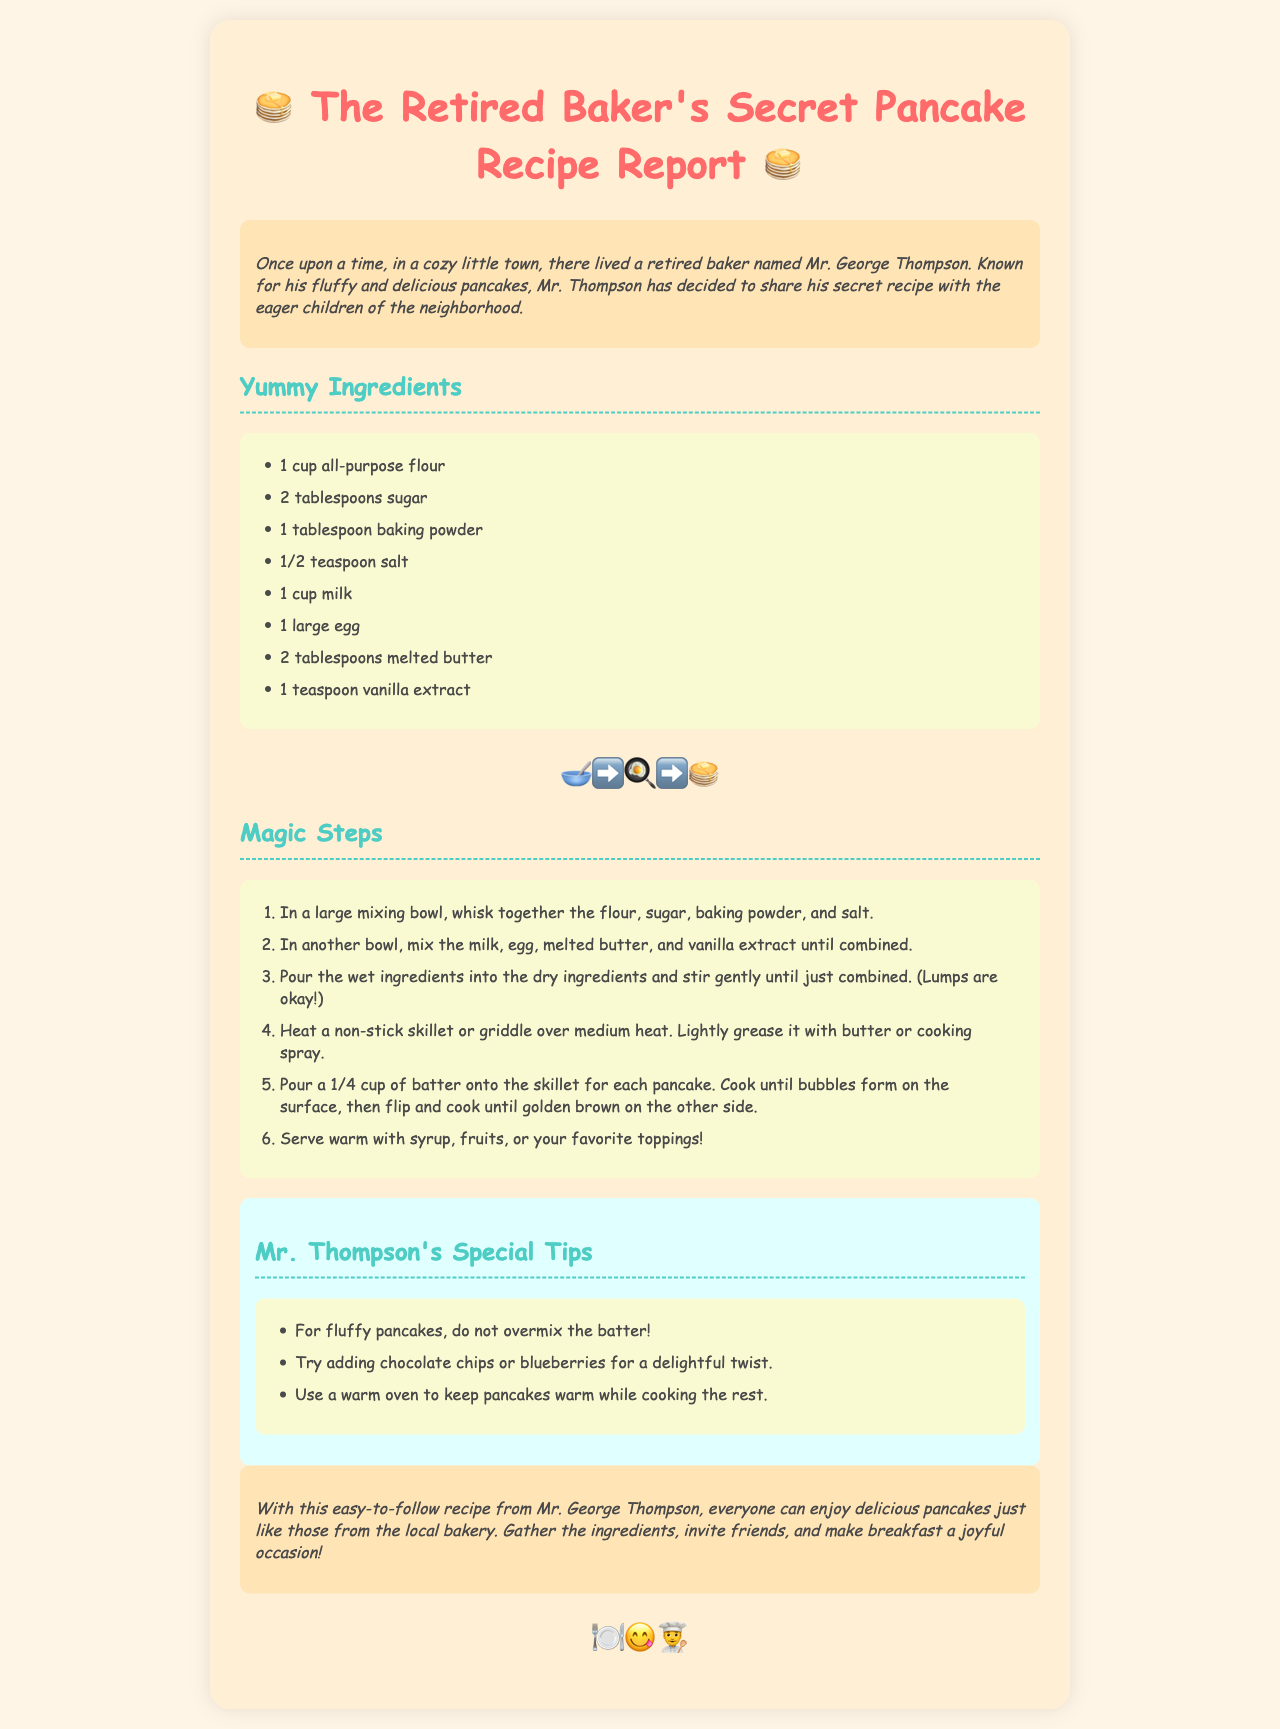what is the name of the retired baker? The document explicitly states that the retired baker is named Mr. George Thompson.
Answer: Mr. George Thompson how many tablespoons of sugar are used? The recipe lists 2 tablespoons of sugar as part of the ingredients.
Answer: 2 tablespoons what should you mix together in the first step? The first step mentions whisking together flour, sugar, baking powder, and salt.
Answer: flour, sugar, baking powder, and salt what is a special tip for fluffy pancakes? The document advises not to overmix the batter for achieving fluffy pancakes.
Answer: do not overmix the batter what is the total number of ingredients listed? By counting the items in the ingredients list, there are 8 items mentioned.
Answer: 8 how many steps are there in the cooking process? The cooking process consists of 6 distinct steps according to the numbered list in the document.
Answer: 6 which ingredient is used to grease the skillet? The instructions specify using butter or cooking spray to lightly grease the skillet.
Answer: butter or cooking spray what is one suggested topping for the pancakes? The document mentions serving pancakes with syrup, fruits, or your favorite toppings as suggestions.
Answer: syrup 